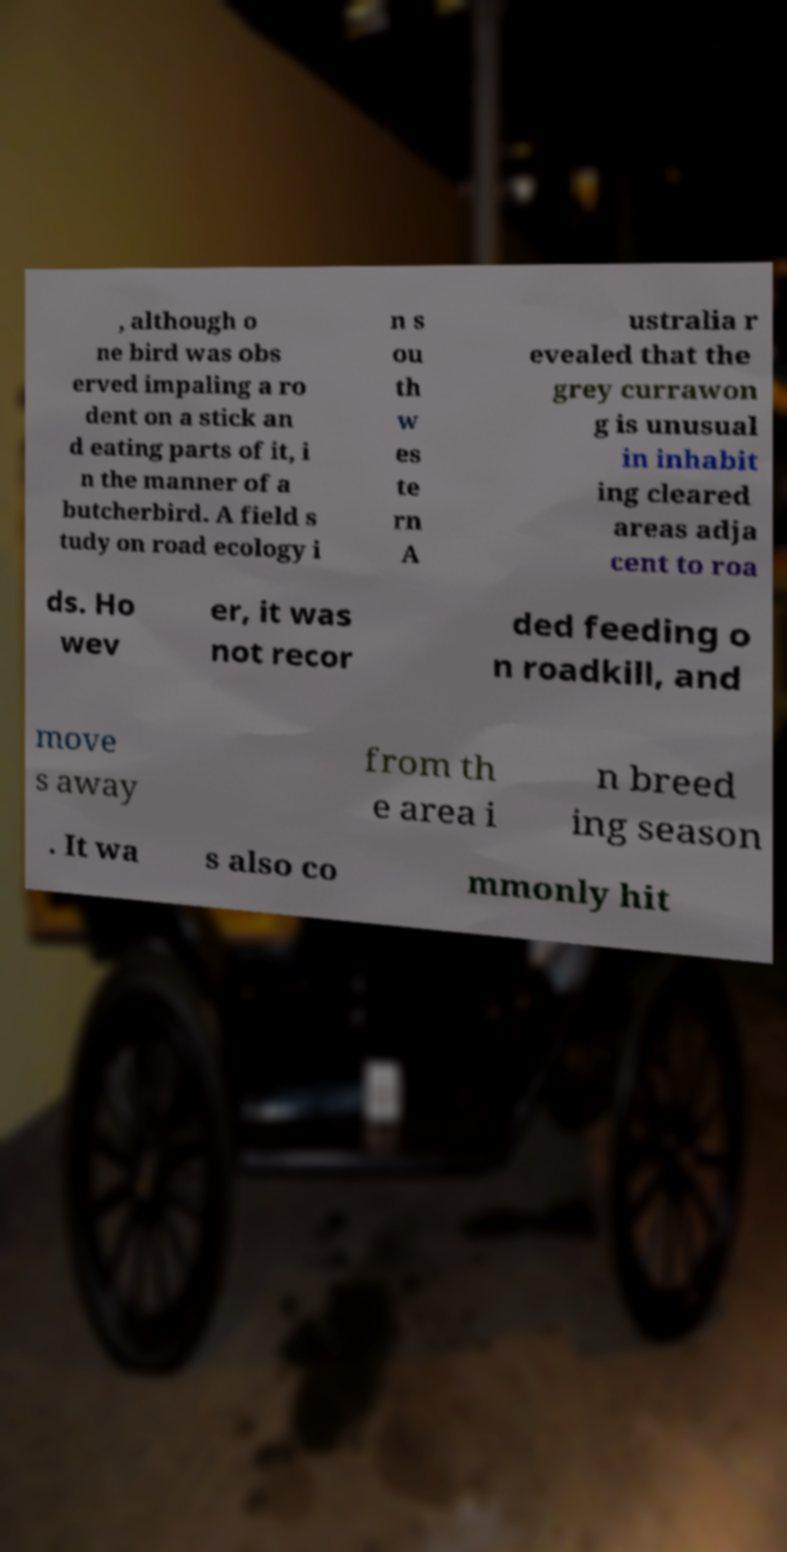There's text embedded in this image that I need extracted. Can you transcribe it verbatim? , although o ne bird was obs erved impaling a ro dent on a stick an d eating parts of it, i n the manner of a butcherbird. A field s tudy on road ecology i n s ou th w es te rn A ustralia r evealed that the grey currawon g is unusual in inhabit ing cleared areas adja cent to roa ds. Ho wev er, it was not recor ded feeding o n roadkill, and move s away from th e area i n breed ing season . It wa s also co mmonly hit 